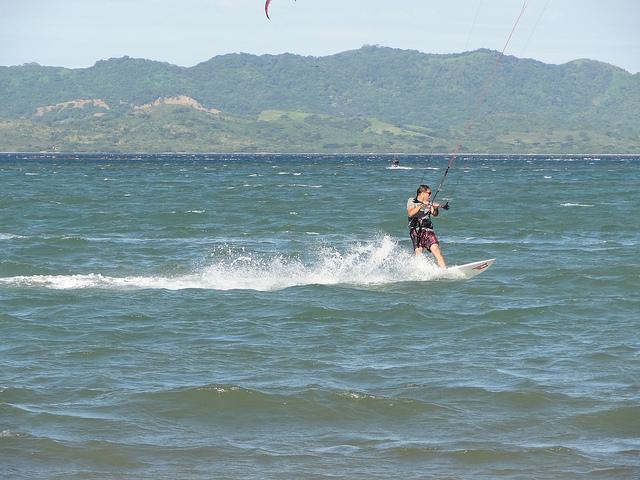What type of water is the man using?
Answer briefly. Lake. Is this person near the shore?
Answer briefly. No. What is at the end of his rope?
Keep it brief. Kite. Are there any birds in the sky?
Concise answer only. No. Is this a river or ocean?
Give a very brief answer. Ocean. 